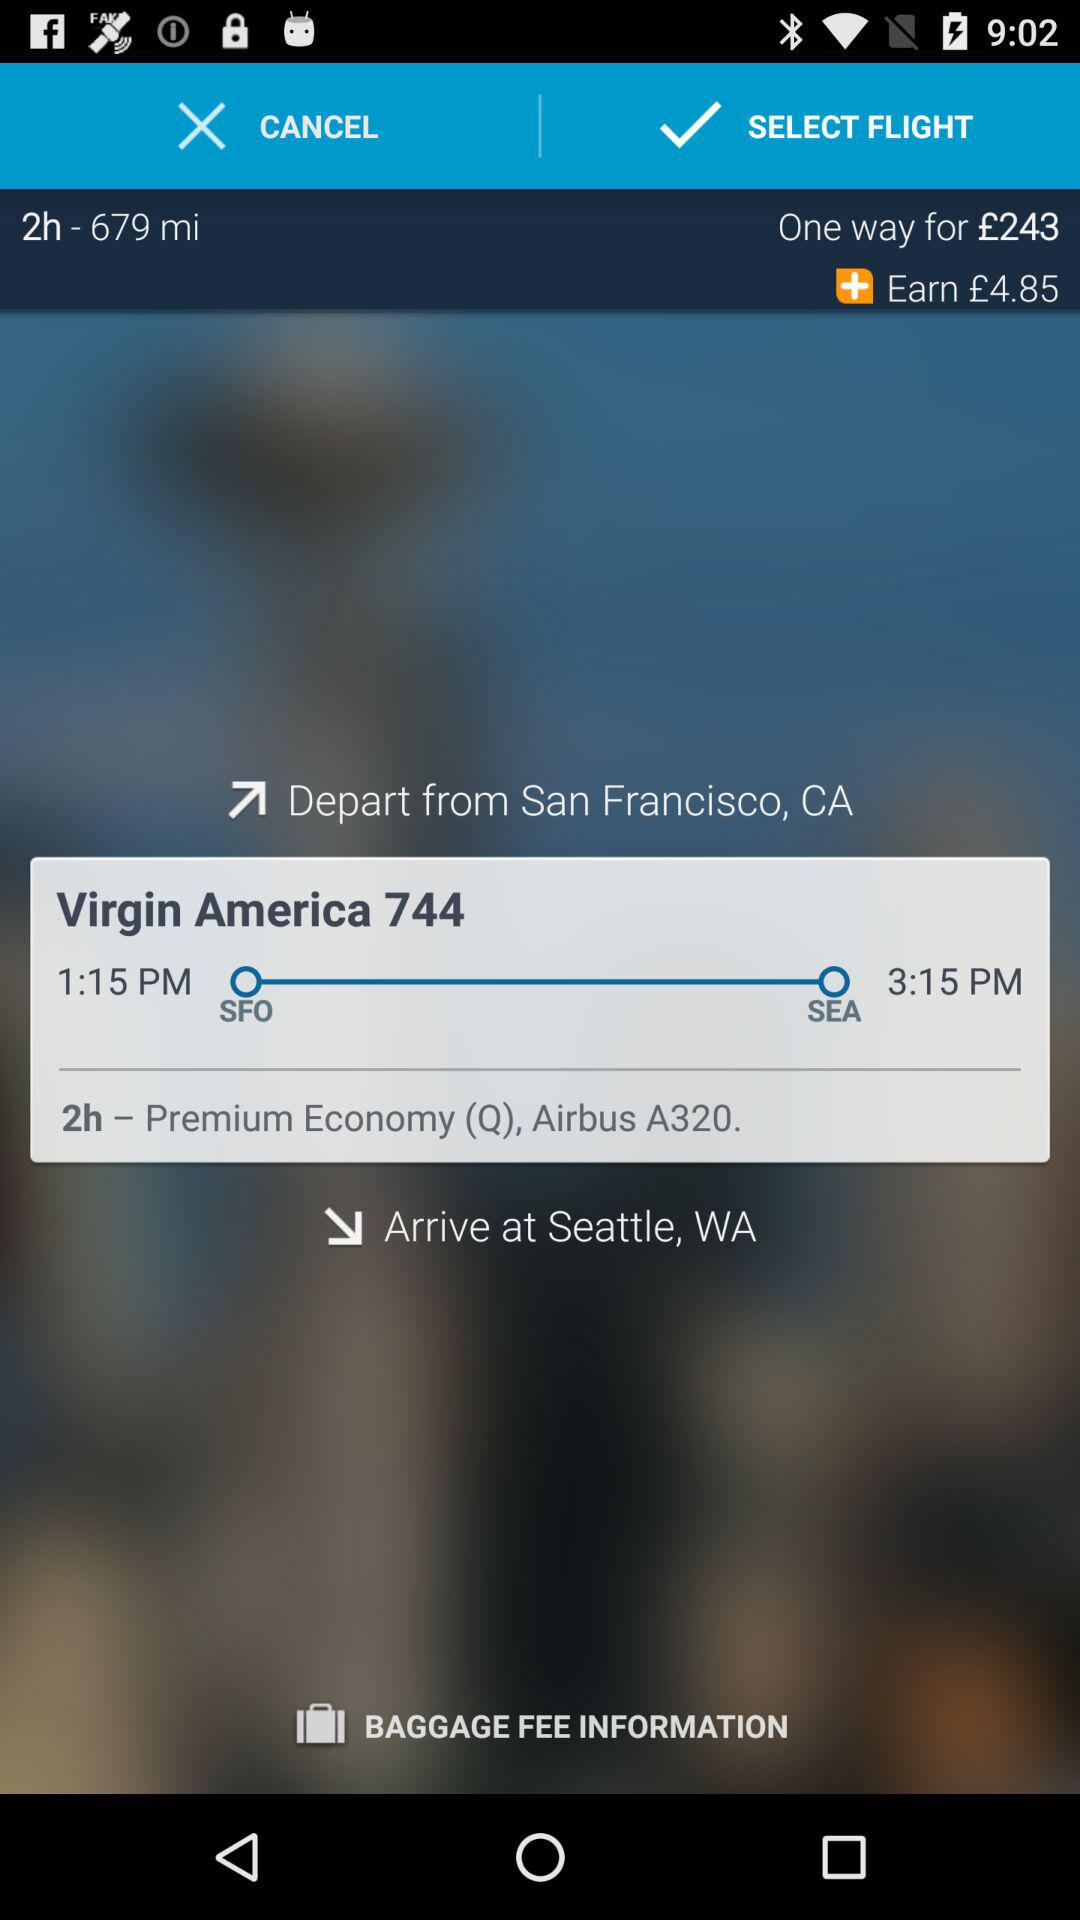What is the time duration of the journey? The time duration of the journey is 2 hours. 